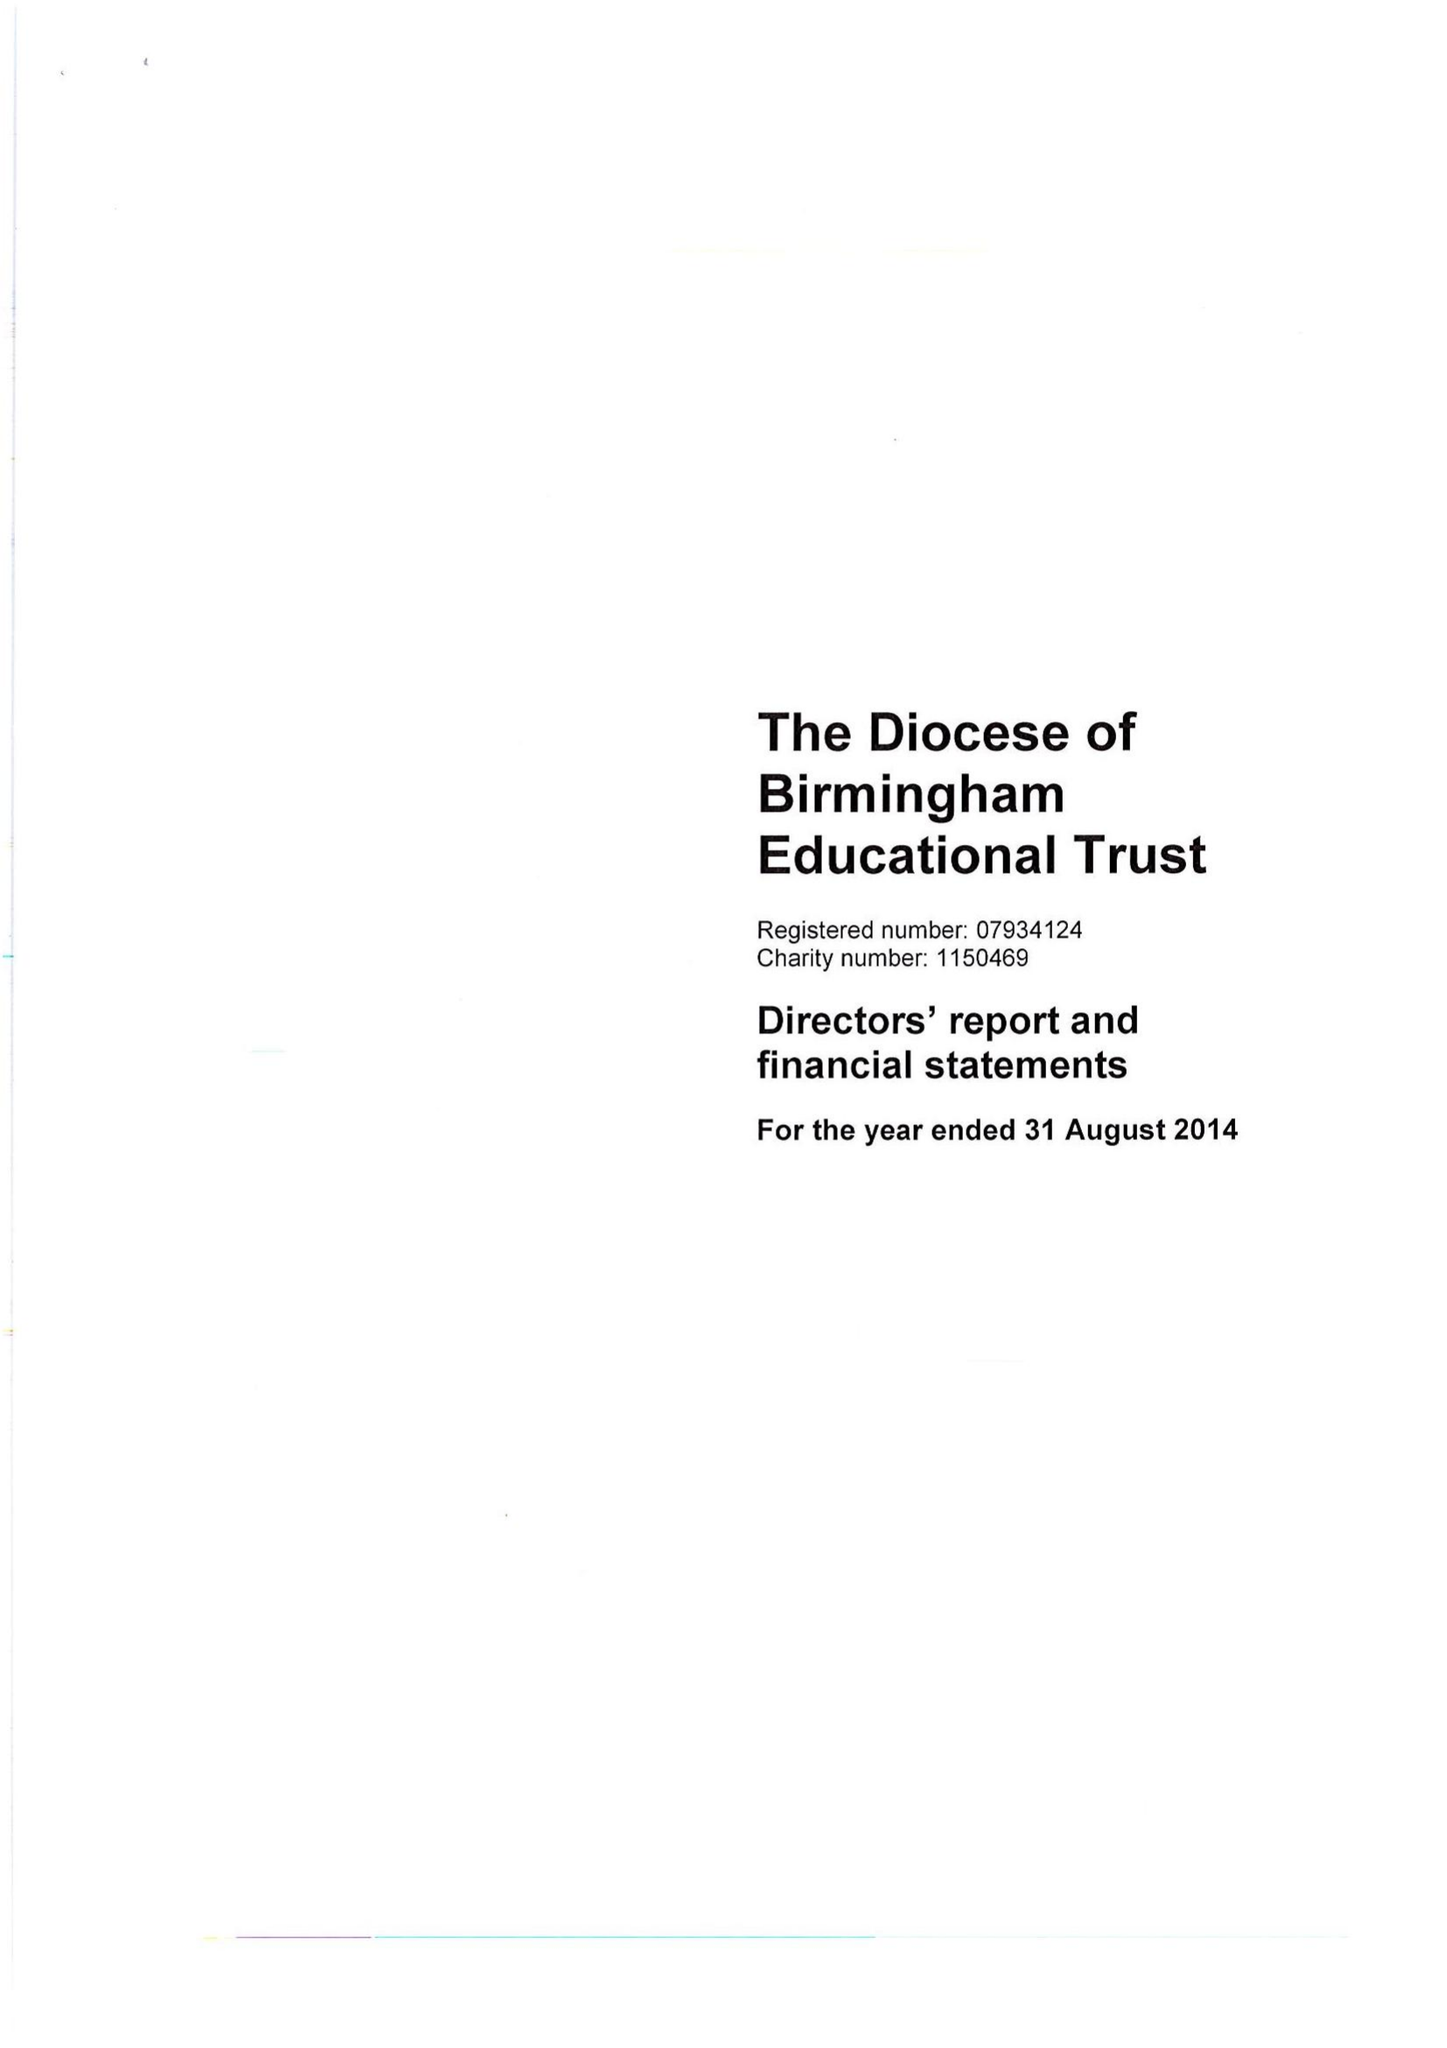What is the value for the address__postcode?
Answer the question using a single word or phrase. B3 2BJ 